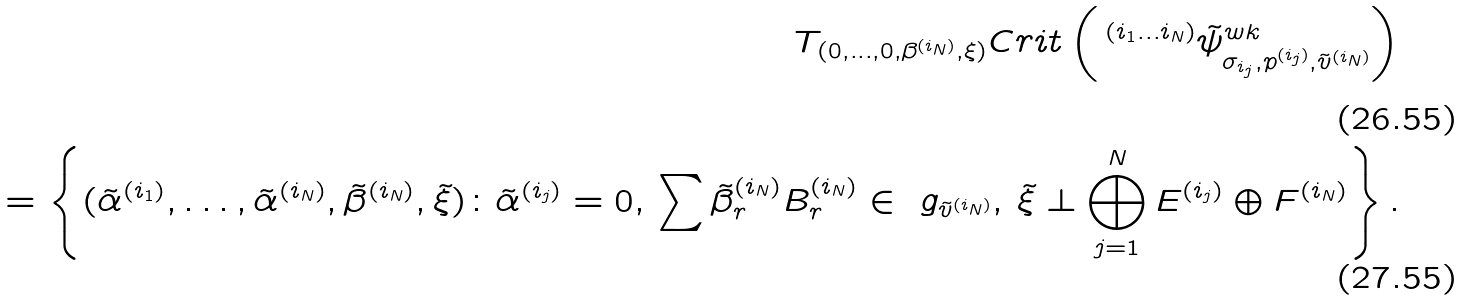Convert formula to latex. <formula><loc_0><loc_0><loc_500><loc_500>T _ { ( 0 , \dots , 0 , \beta ^ { ( i _ { N } ) } , \xi ) } C r i t \left ( \, ^ { ( i _ { 1 } \dots i _ { N } ) } \tilde { \psi } ^ { w k } _ { \sigma _ { i _ { j } } , p ^ { ( i _ { j } ) } , \tilde { v } ^ { ( i _ { N } ) } } \right ) \\ = \left \{ ( \tilde { \alpha } ^ { ( i _ { 1 } ) } , \dots , \tilde { \alpha } ^ { ( i _ { N } ) } , \tilde { \beta } ^ { ( i _ { N } ) } , \tilde { \xi } ) \colon \tilde { \alpha } ^ { ( i _ { j } ) } = 0 , \, \sum \tilde { \beta } ^ { ( i _ { N } ) } _ { r } B ^ { ( i _ { N } ) } _ { r } \in \ g _ { \tilde { v } ^ { ( i _ { N } ) } } , \, \tilde { \xi } \perp \bigoplus _ { j = 1 } ^ { N } E ^ { ( i _ { j } ) } \oplus F ^ { ( i _ { N } ) } \right \} .</formula> 